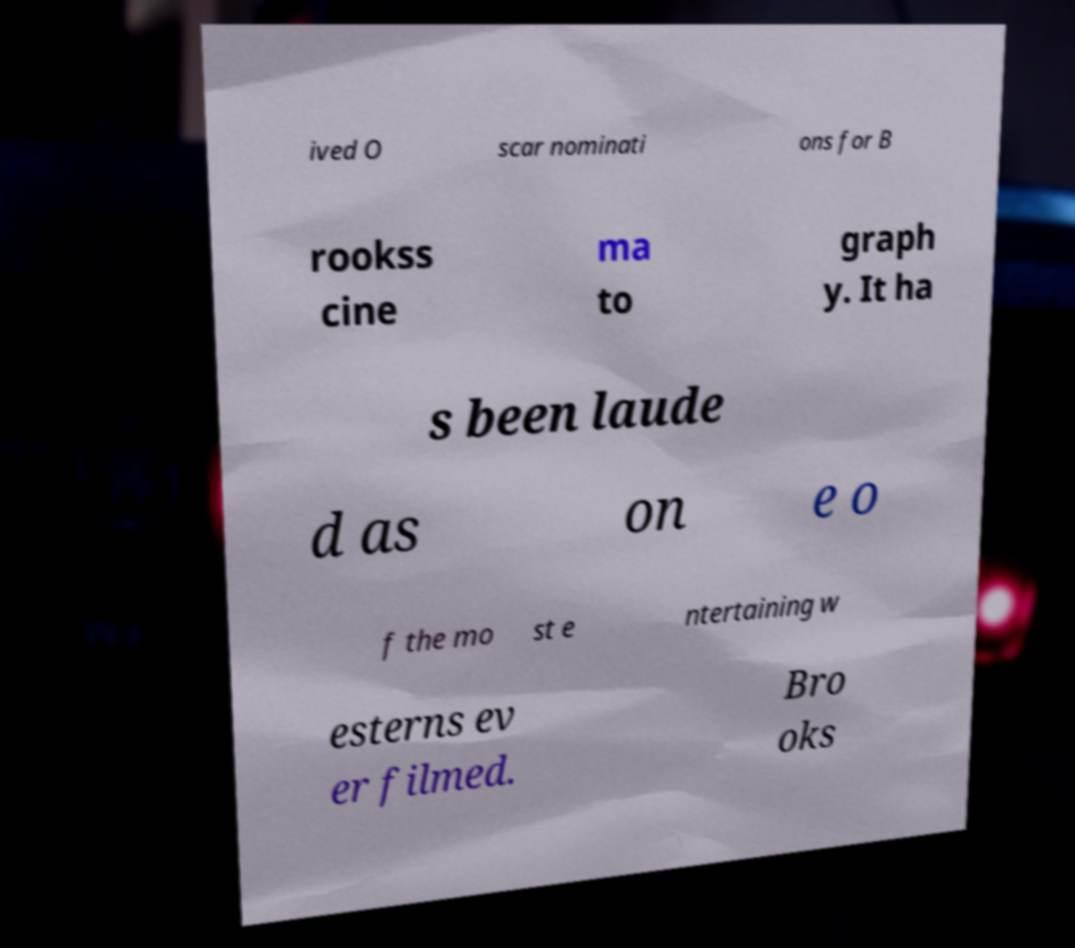There's text embedded in this image that I need extracted. Can you transcribe it verbatim? ived O scar nominati ons for B rookss cine ma to graph y. It ha s been laude d as on e o f the mo st e ntertaining w esterns ev er filmed. Bro oks 